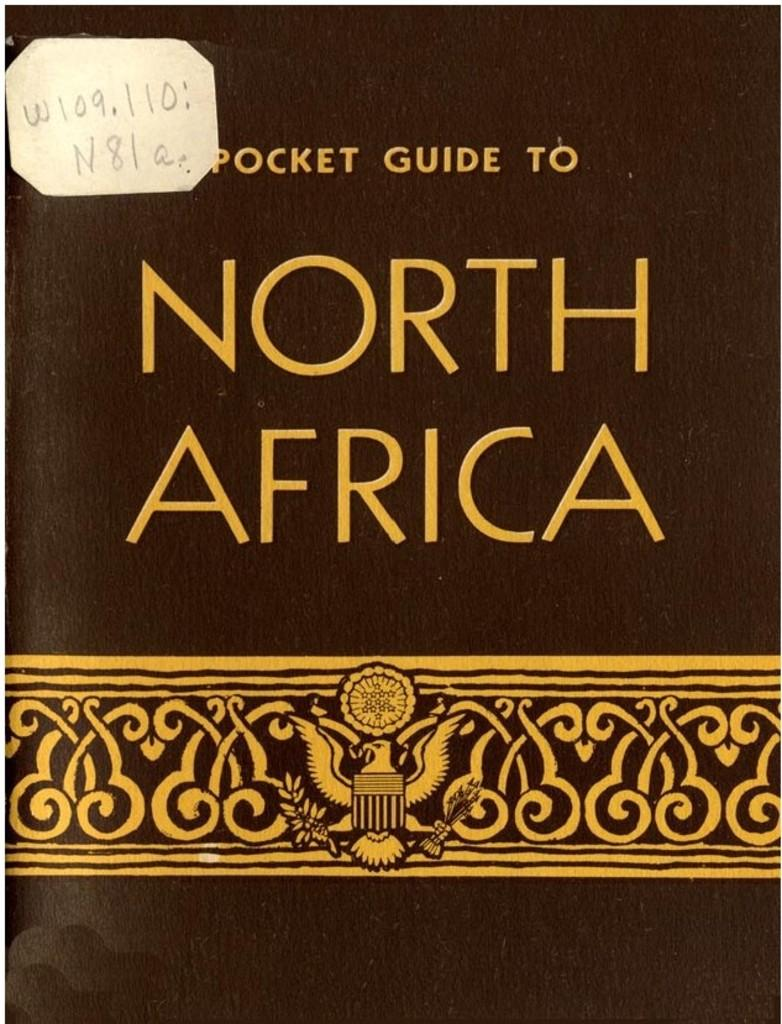<image>
Relay a brief, clear account of the picture shown. A black book called Pocket Guide to North Africa 